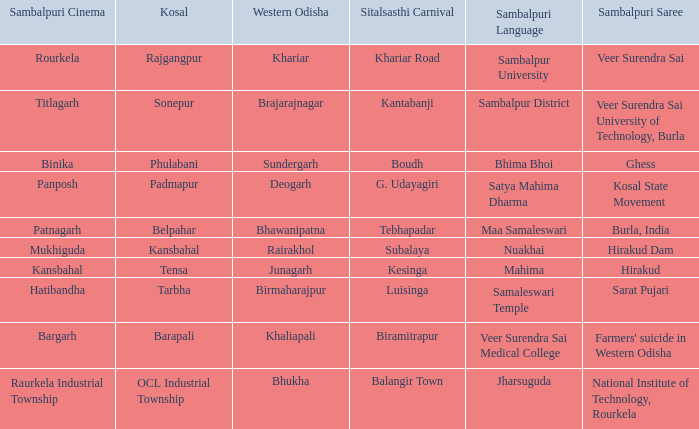What is the kosal with hatibandha as the sambalpuri cinema? Tarbha. 